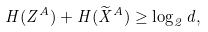<formula> <loc_0><loc_0><loc_500><loc_500>H ( Z ^ { A } ) + H ( \widetilde { X } ^ { A } ) \geq \log _ { 2 } d ,</formula> 